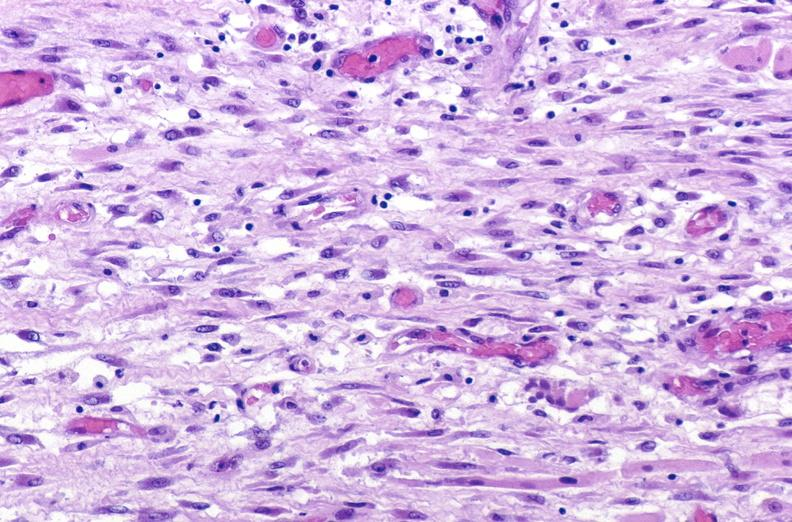s muscle present?
Answer the question using a single word or phrase. Yes 